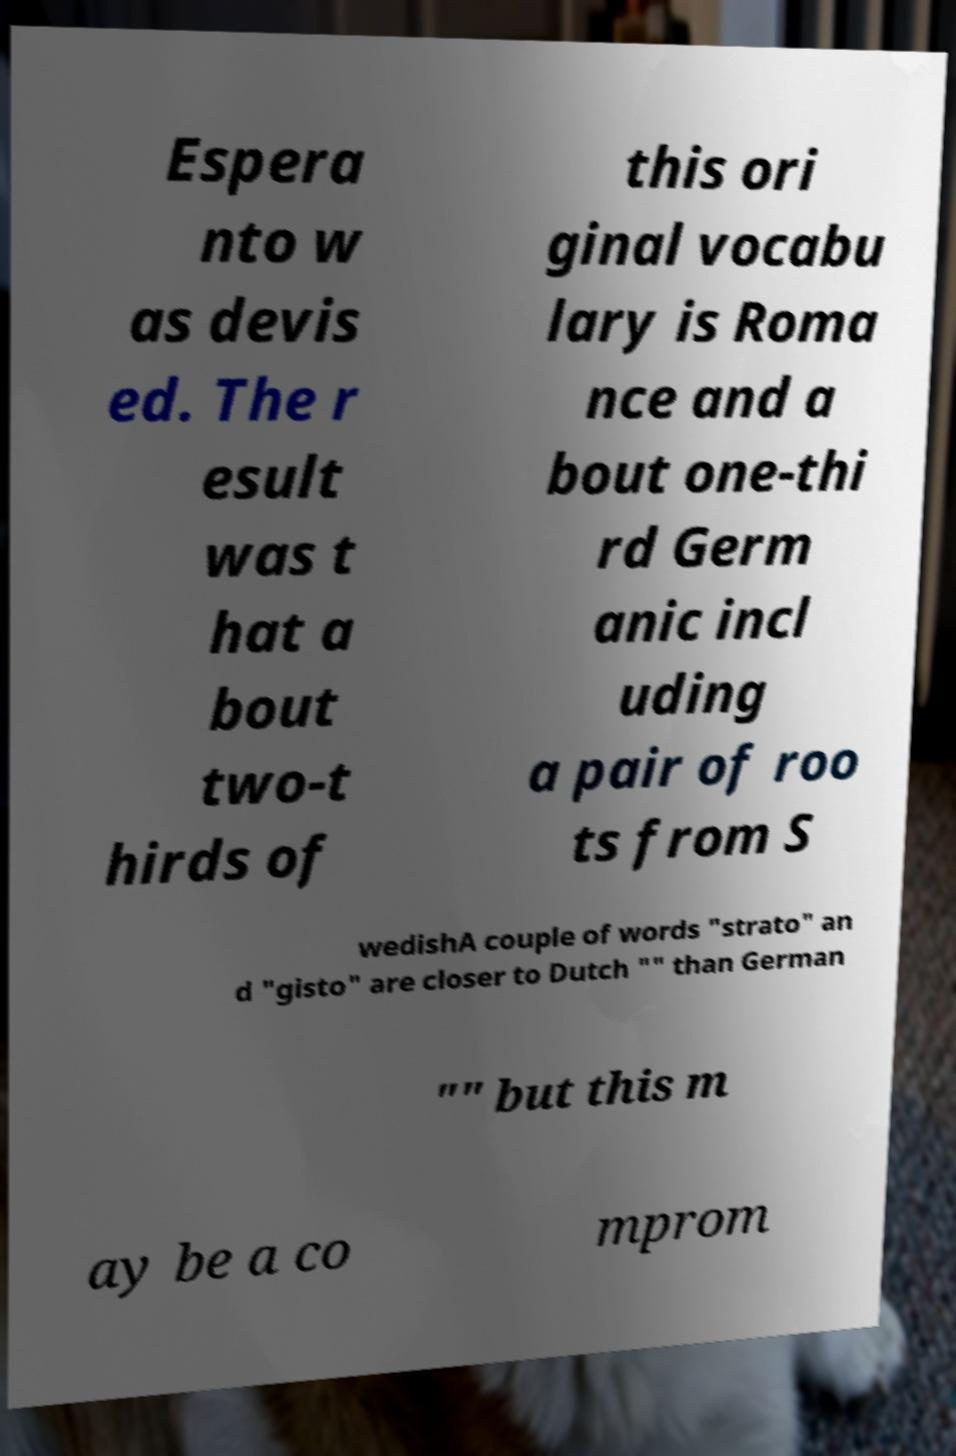Could you assist in decoding the text presented in this image and type it out clearly? Espera nto w as devis ed. The r esult was t hat a bout two-t hirds of this ori ginal vocabu lary is Roma nce and a bout one-thi rd Germ anic incl uding a pair of roo ts from S wedishA couple of words "strato" an d "gisto" are closer to Dutch "" than German "" but this m ay be a co mprom 